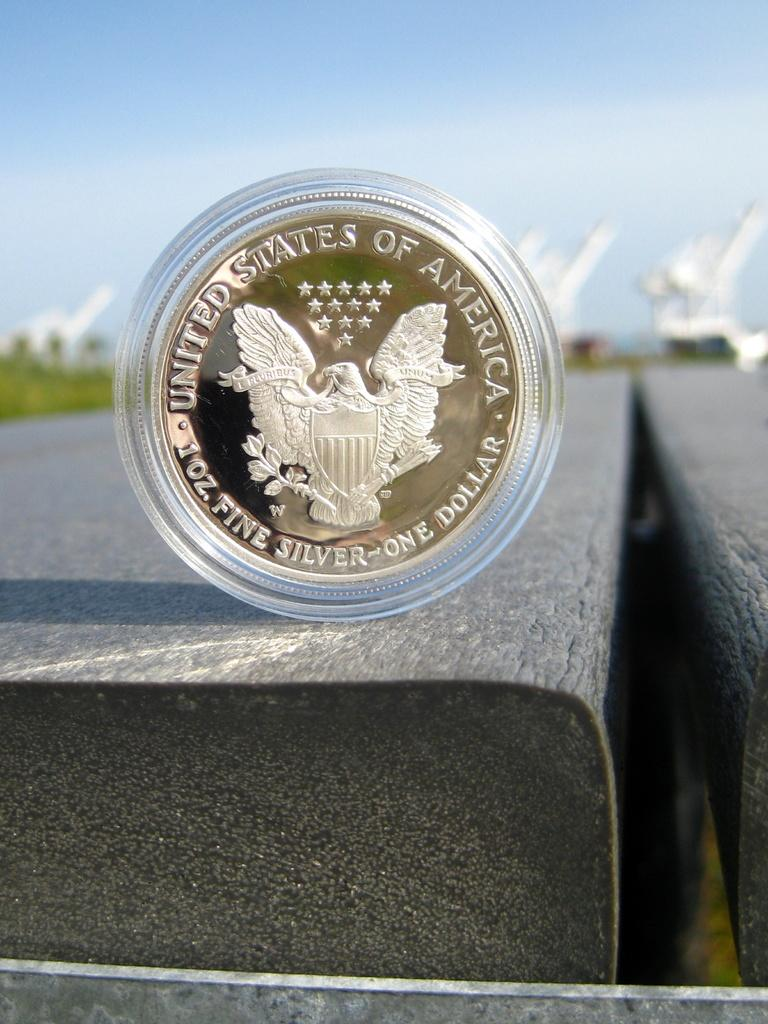What type of object is in the center of the image? There is an American coin in the center of the image. Can you describe the position of the coin in the image? The coin is in the center of the image. What type of guitar is the boy playing in the image? There is no boy or guitar present in the image; it only features an American coin. 